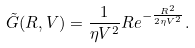Convert formula to latex. <formula><loc_0><loc_0><loc_500><loc_500>\tilde { G } ( R , V ) = \frac { 1 } { \eta V ^ { 2 } } R e ^ { - \frac { R ^ { 2 } } { 2 \eta V ^ { 2 } } } .</formula> 